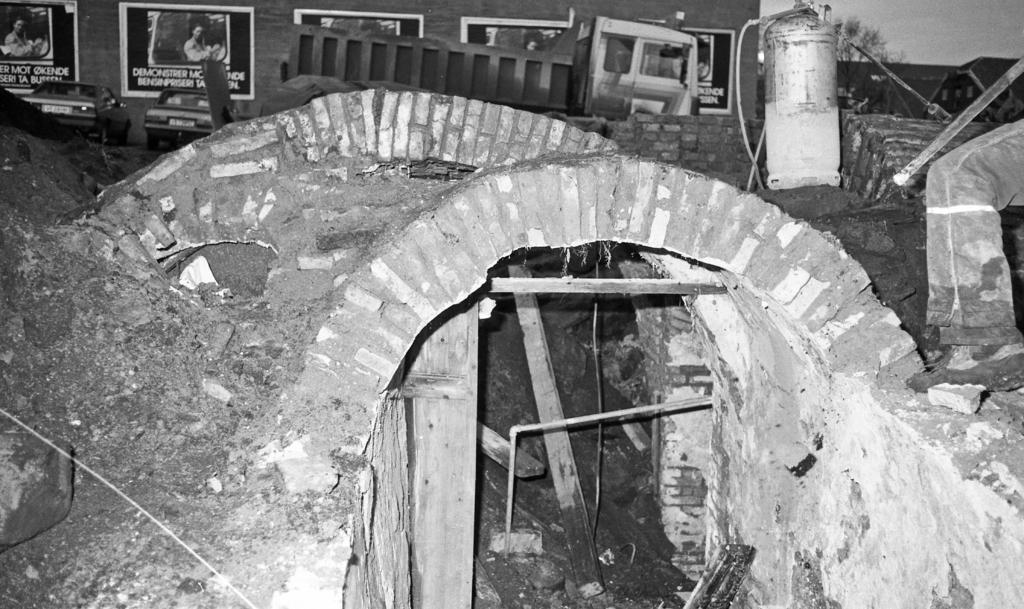How would you summarize this image in a sentence or two? This is a black and white image. In the center of the image there is a tunnel. In the background of the image There are vehicles. There is a wall with posters on it. To the right side of the image there is object. 